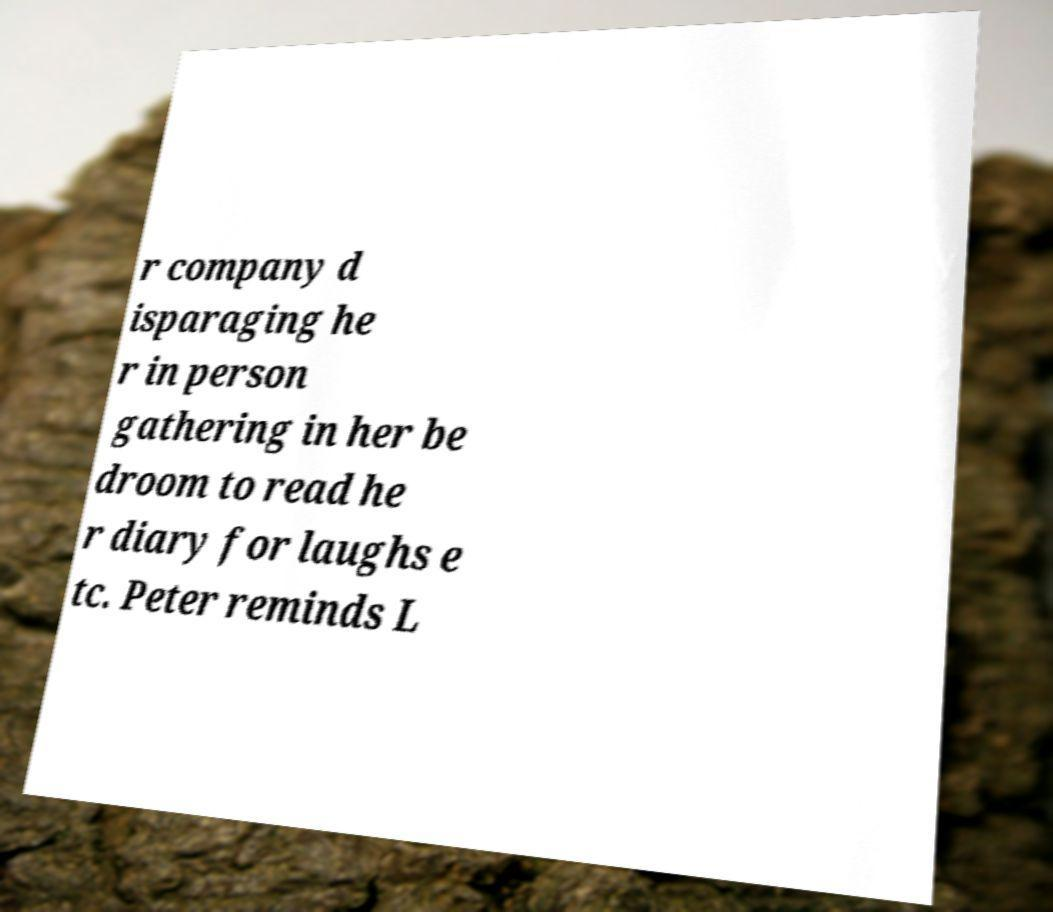Could you assist in decoding the text presented in this image and type it out clearly? r company d isparaging he r in person gathering in her be droom to read he r diary for laughs e tc. Peter reminds L 